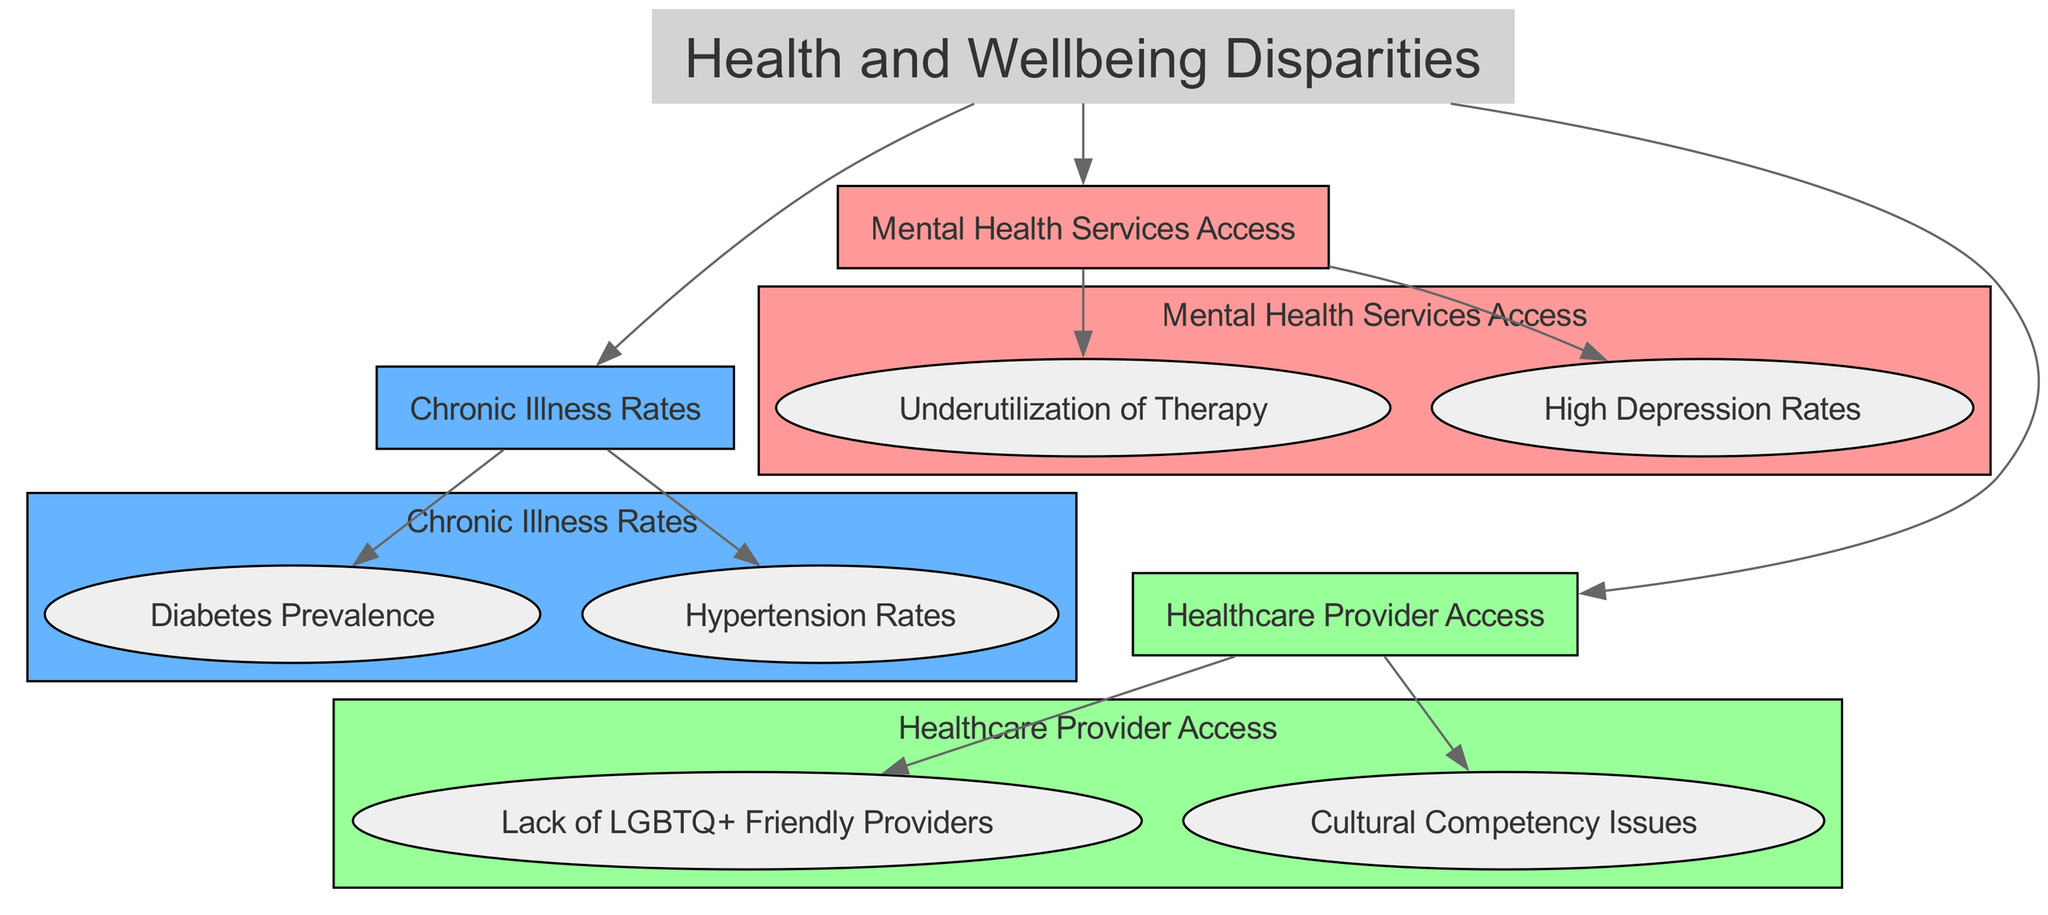What is the main title of the infographic? The title node labeled "Health and Wellbeing Disparities" provides the main topic of the diagram.
Answer: Health and Wellbeing Disparities How many categories of health disparities are represented in the diagram? The diagram contains three main categories: Mental Health Services Access, Chronic Illness Rates, and Healthcare Provider Access.
Answer: 3 Which data point relates to mental health services access? The data points under the Mental Health Services Access category include "Underutilization of Therapy" and "High Depression Rates."
Answer: Underutilization of Therapy What chronic illness has the highest prevalence indicated in the diagram? The "Diabetes Prevalence" data point identifies one of the chronic illnesses and is grouped under Chronic Illness Rates. It suggests a notable prevalence in the community but does not compare rates among other illnesses in this context.
Answer: Diabetes Prevalence What is a significant barrier to healthcare provider access indicated in the diagram? The data point "Lack of LGBTQ+ Friendly Providers" highlights a critical issue indicating that there are not enough healthcare providers who are sensitive to LGBTQ+ needs.
Answer: Lack of LGBTQ+ Friendly Providers How do "High Depression Rates" compare to "Underutilization of Therapy"? Both data points stem from the same category of Mental Health Services Access but describe different aspects; "High Depression Rates" indicate a problem's severity while "Underutilization of Therapy" refers to a potential solution that is not being sought.
Answer: Related What colors are used to represent the categories in the diagram? Each category (Mental Health Services Access, Chronic Illness Rates, Healthcare Provider Access) is associated with specific colors: #ff9999 for Mental Health Services Access, #66b3ff for Chronic Illness Rates, and #99ff99 for Healthcare Provider Access.
Answer: #ff9999, #66b3ff, #99ff99 Which data points point to cultural issues in healthcare? The nodes "Lack of LGBTQ+ Friendly Providers" and "Cultural Competency Issues" are specifically pointed out under Healthcare Provider Access, indicating these cultural barriers affecting access to healthcare.
Answer: Cultural Competency Issues What connection can be drawn from high depression rates to the underutilization of therapy? The relationship implies that higher depression rates among the community may lead to lower utilization rates of mental health therapies, suggesting possible stigma, lack of resources, or accessibility issues.
Answer: Interlinked 